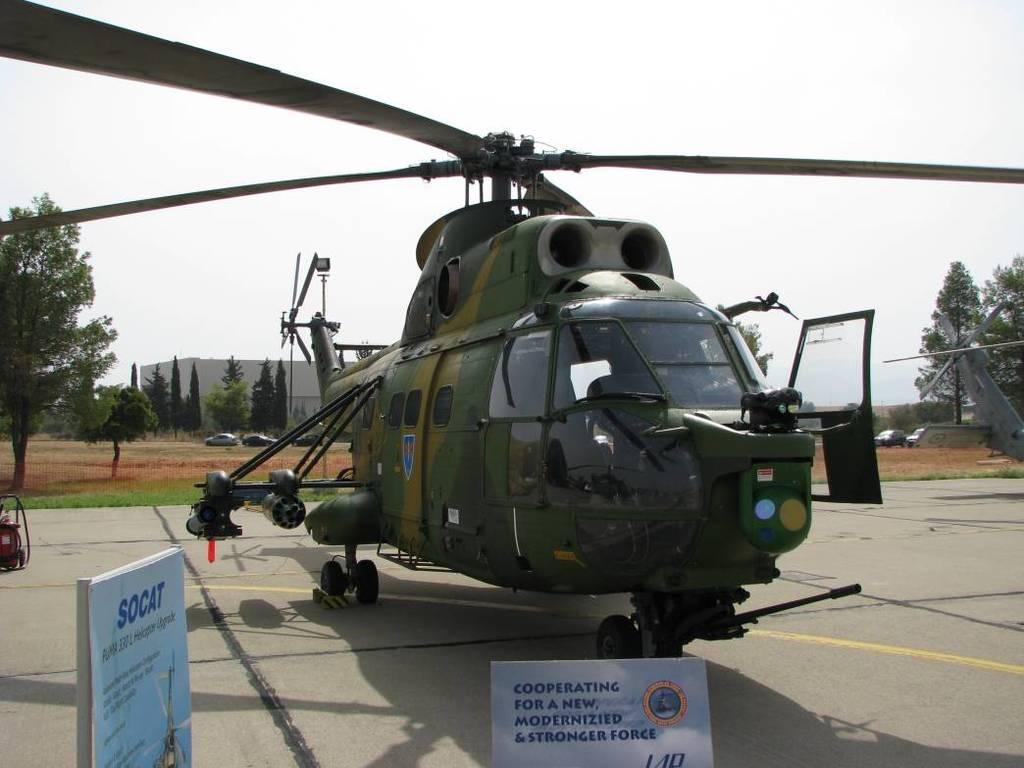Provide a one-sentence caption for the provided image. a army helicopter on the ground with sings around, one says SOCAT on it but it's blurry. 